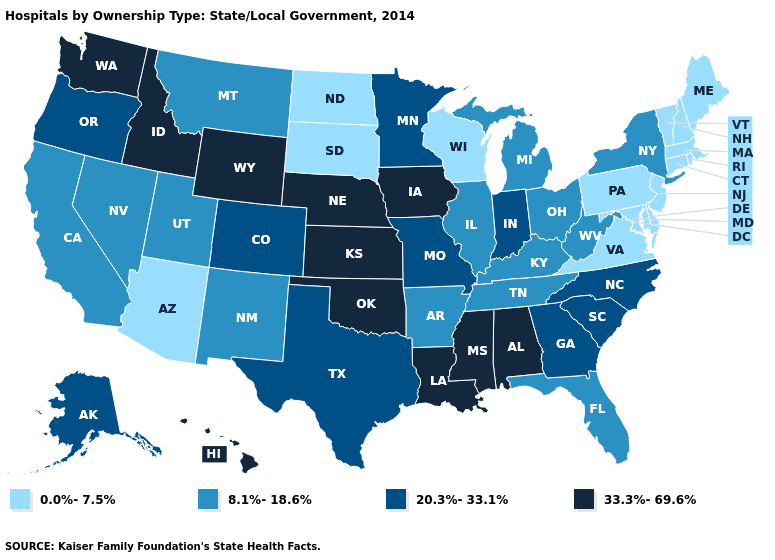How many symbols are there in the legend?
Quick response, please. 4. What is the lowest value in the MidWest?
Answer briefly. 0.0%-7.5%. What is the value of Minnesota?
Keep it brief. 20.3%-33.1%. What is the value of Kansas?
Concise answer only. 33.3%-69.6%. What is the value of Oklahoma?
Keep it brief. 33.3%-69.6%. Among the states that border Maryland , does Delaware have the highest value?
Concise answer only. No. What is the lowest value in states that border Wyoming?
Short answer required. 0.0%-7.5%. What is the value of Indiana?
Write a very short answer. 20.3%-33.1%. Among the states that border Arkansas , which have the lowest value?
Give a very brief answer. Tennessee. Which states have the lowest value in the MidWest?
Concise answer only. North Dakota, South Dakota, Wisconsin. Does Texas have the same value as Idaho?
Give a very brief answer. No. What is the lowest value in states that border Ohio?
Be succinct. 0.0%-7.5%. Name the states that have a value in the range 0.0%-7.5%?
Concise answer only. Arizona, Connecticut, Delaware, Maine, Maryland, Massachusetts, New Hampshire, New Jersey, North Dakota, Pennsylvania, Rhode Island, South Dakota, Vermont, Virginia, Wisconsin. Name the states that have a value in the range 8.1%-18.6%?
Quick response, please. Arkansas, California, Florida, Illinois, Kentucky, Michigan, Montana, Nevada, New Mexico, New York, Ohio, Tennessee, Utah, West Virginia. 